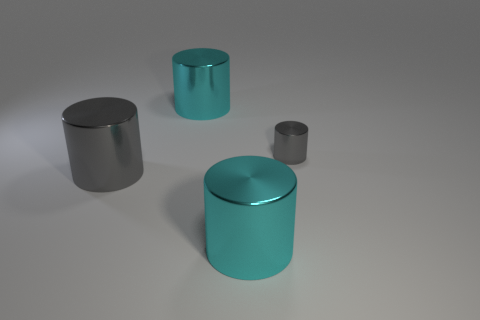Is the tiny gray cylinder made of the same material as the big gray cylinder?
Offer a very short reply. Yes. What shape is the cyan shiny object that is in front of the small cylinder?
Provide a succinct answer. Cylinder. Are there any large cyan shiny cylinders that are left of the large object behind the small gray shiny cylinder?
Give a very brief answer. No. Is the color of the large shiny object that is behind the big gray cylinder the same as the tiny object?
Ensure brevity in your answer.  No. There is a gray thing on the right side of the big metal thing in front of the big gray cylinder; what is its size?
Your answer should be compact. Small. How many big shiny things are the same color as the tiny thing?
Give a very brief answer. 1. How many big purple cubes are there?
Give a very brief answer. 0. What number of big things are made of the same material as the tiny object?
Provide a succinct answer. 3. There is another gray object that is the same shape as the tiny gray object; what size is it?
Give a very brief answer. Large. What material is the small cylinder?
Make the answer very short. Metal. 